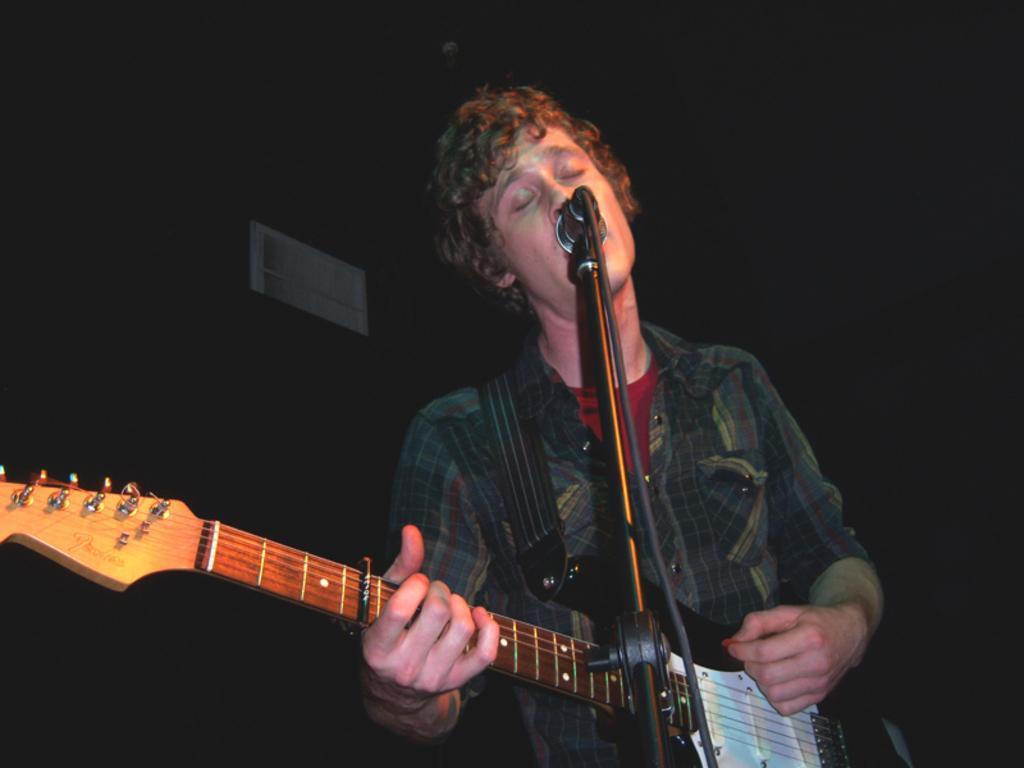Please provide a concise description of this image. Background is completely dark. We can see one man standing in front of a mike and playing guitar. 